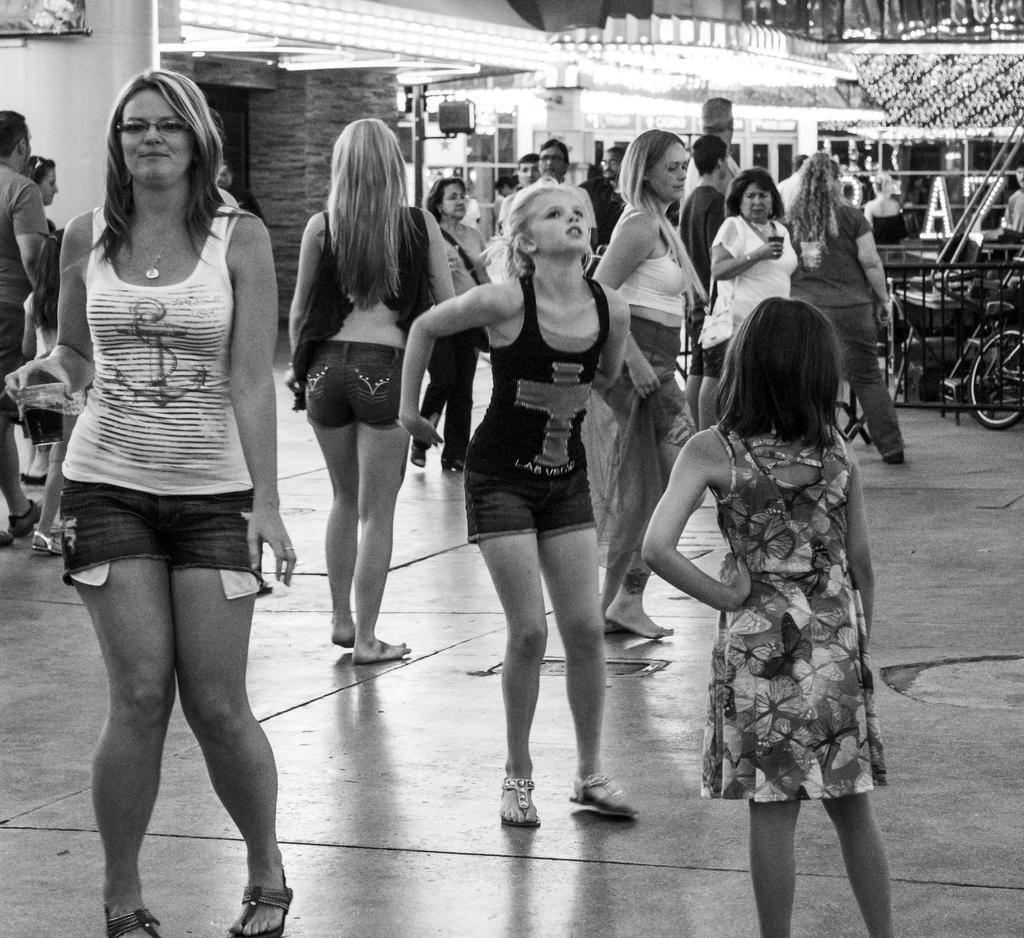In one or two sentences, can you explain what this image depicts? In this picture we can see a group of people standing on the floor, bicycle and in the background we can see the lights, pillars. 